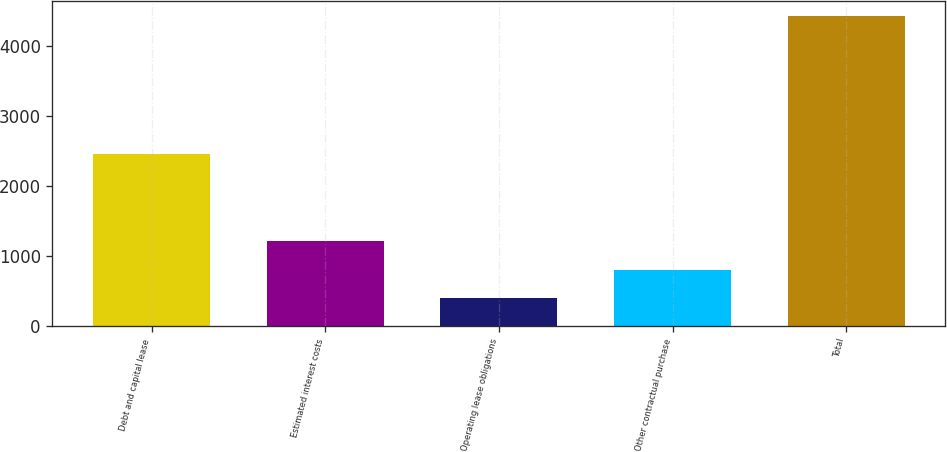Convert chart. <chart><loc_0><loc_0><loc_500><loc_500><bar_chart><fcel>Debt and capital lease<fcel>Estimated interest costs<fcel>Operating lease obligations<fcel>Other contractual purchase<fcel>Total<nl><fcel>2453<fcel>1208.6<fcel>406<fcel>807.3<fcel>4419<nl></chart> 